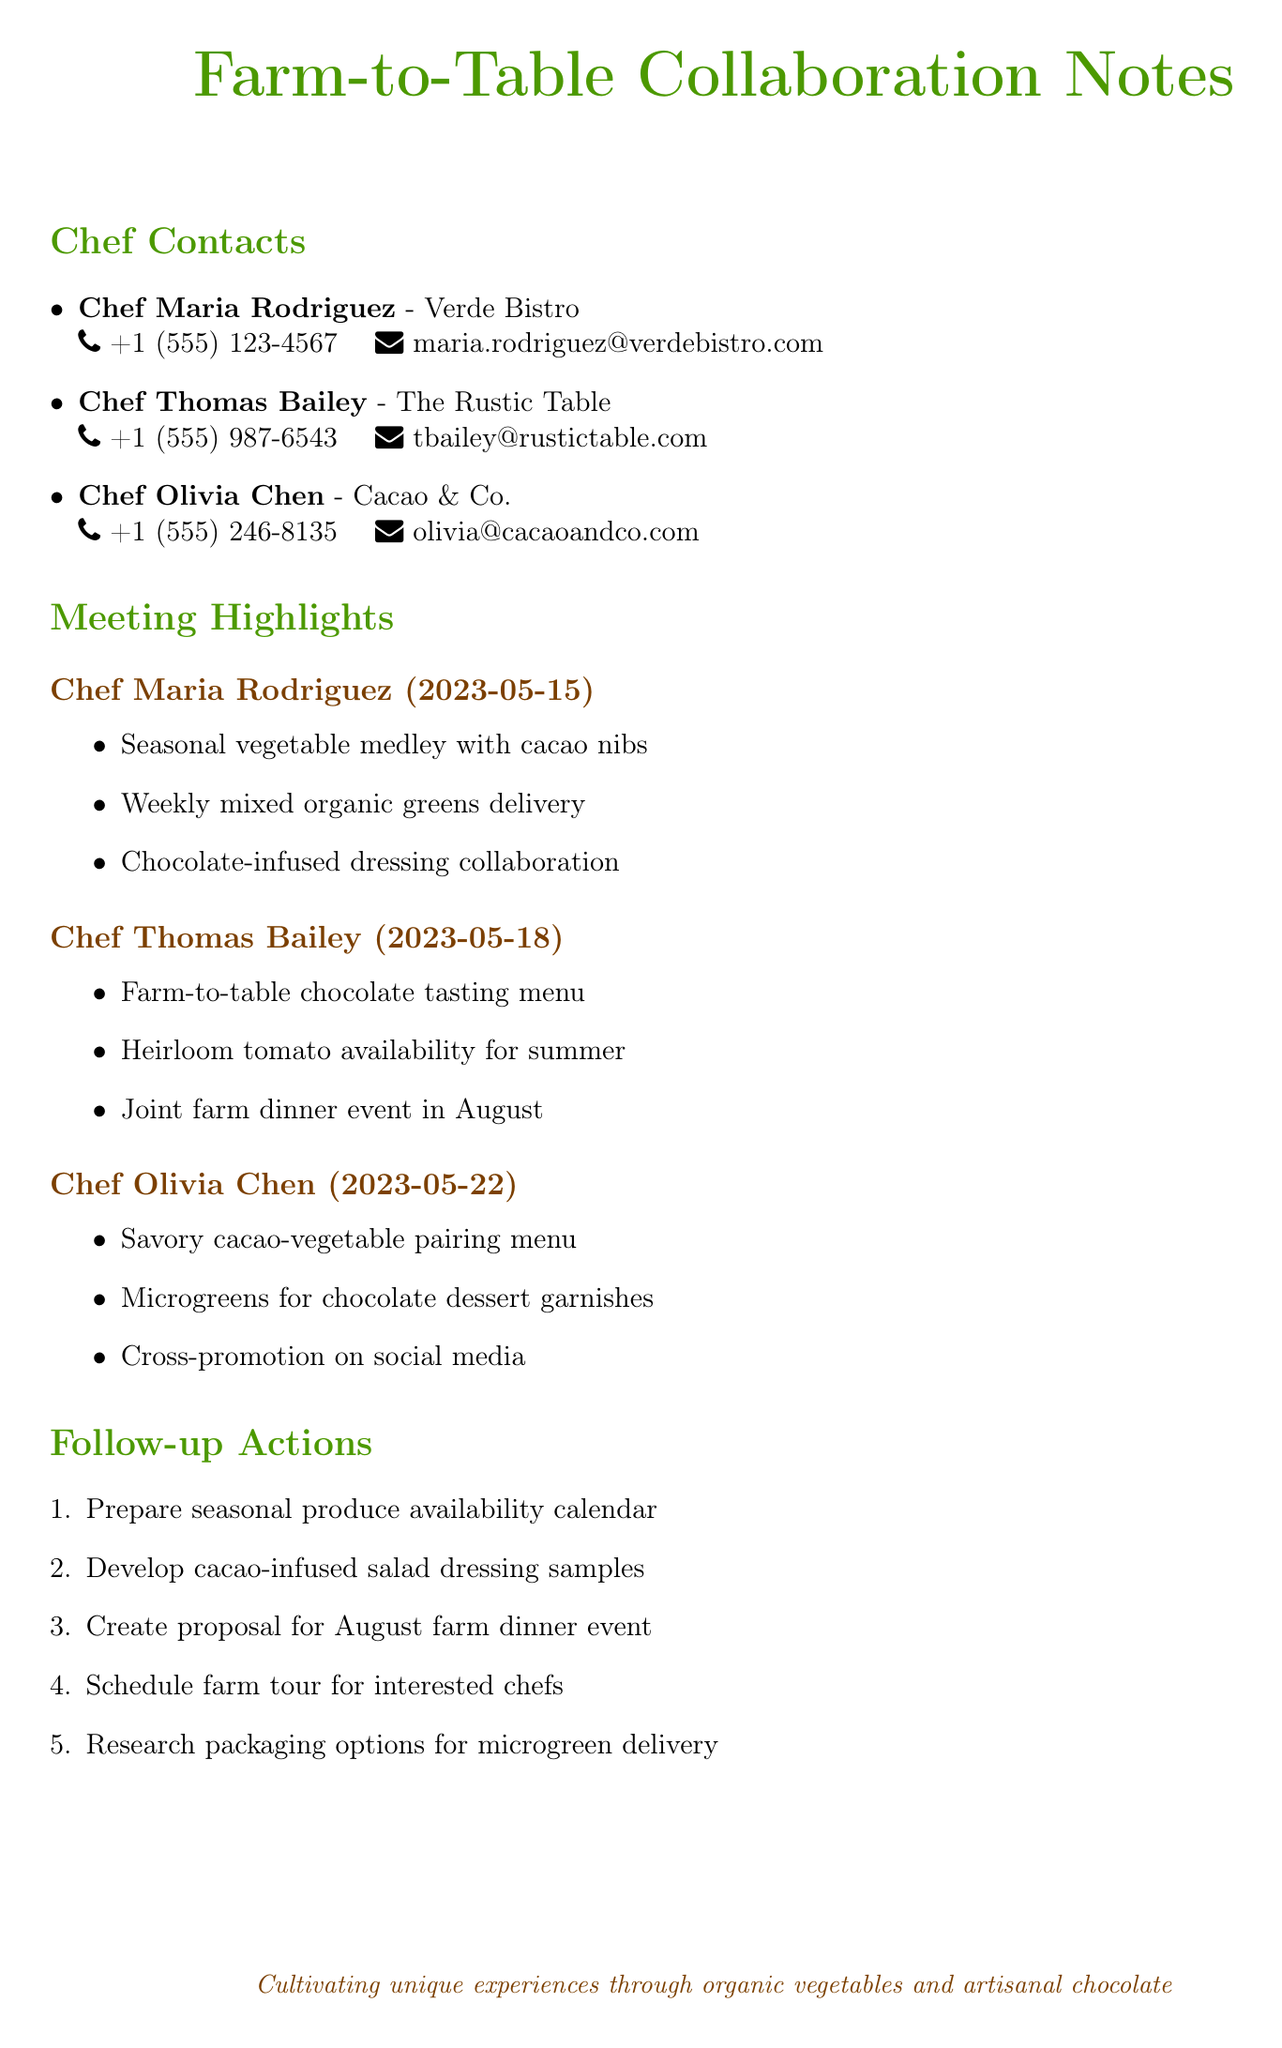what is the name of the chef who works at Verde Bistro? The document lists Chef Maria Rodriguez as the chef at Verde Bistro.
Answer: Chef Maria Rodriguez what is the phone number of Chef Thomas Bailey? The document states that Chef Thomas Bailey's phone number is +1 (555) 987-6543.
Answer: +1 (555) 987-6543 on which date did the meeting with Chef Olivia Chen occur? The meeting notes indicate that the meeting with Chef Olivia Chen took place on May 22, 2023.
Answer: 2023-05-22 what key point did Chef Maria Rodriguez express interest in? The document mentions that Chef Maria Rodriguez is interested in a seasonal vegetable medley featuring cacao nibs.
Answer: seasonal vegetable medley featuring cacao nibs which restaurant is associated with Chef Olivia Chen? According to the document, Chef Olivia Chen works at Cacao & Co.
Answer: Cacao & Co how many follow-up actions are listed in the document? The document enumerates five follow-up actions that need to be taken.
Answer: 5 what is one of the proposed ideas from Chef Thomas Bailey? Chef Thomas Bailey suggested hosting a joint farm dinner event in August according to the meeting notes.
Answer: joint farm dinner event in August which chef inquired about heirloom tomato availability for summer? The notes reveal that Chef Thomas Bailey inquired about heirloom tomato availability for the summer menu.
Answer: Chef Thomas Bailey what collaboration did Chef Maria Rodriguez propose? Chef Maria Rodriguez proposed a chocolate-infused dressing collaboration as noted in the meeting highlights.
Answer: chocolate-infused dressing collaboration 